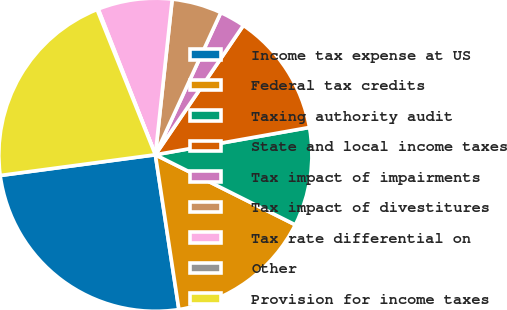<chart> <loc_0><loc_0><loc_500><loc_500><pie_chart><fcel>Income tax expense at US<fcel>Federal tax credits<fcel>Taxing authority audit<fcel>State and local income taxes<fcel>Tax impact of impairments<fcel>Tax impact of divestitures<fcel>Tax rate differential on<fcel>Other<fcel>Provision for income taxes<nl><fcel>25.29%<fcel>15.21%<fcel>10.18%<fcel>12.7%<fcel>2.64%<fcel>5.15%<fcel>7.67%<fcel>0.12%<fcel>21.04%<nl></chart> 